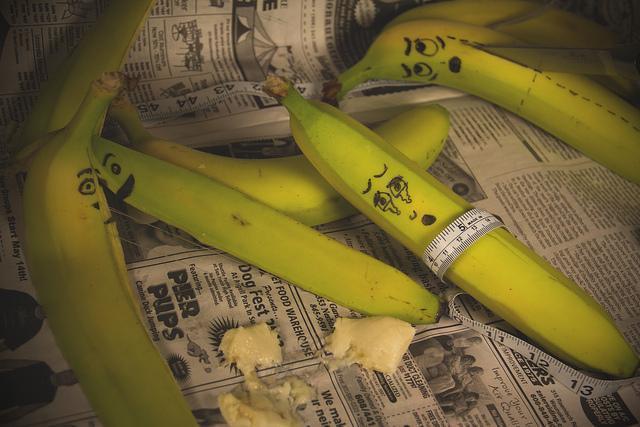How many bananas are there?
Give a very brief answer. 4. 